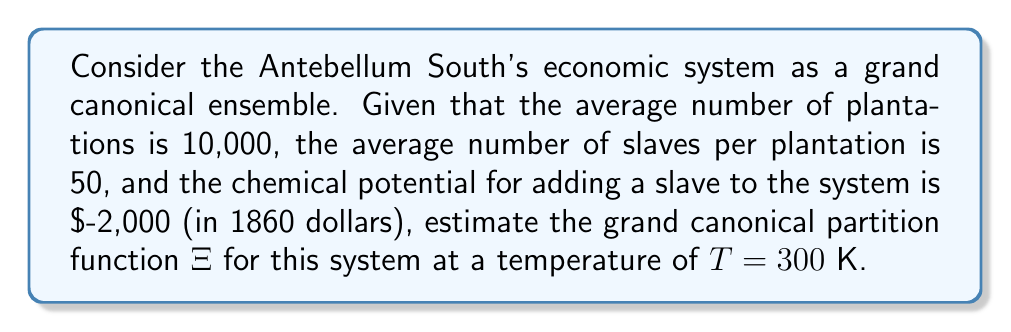What is the answer to this math problem? To estimate the grand canonical partition function for the Antebellum South's economic system, we'll follow these steps:

1) The grand canonical partition function is given by:
   $$\Xi = \sum_{N=0}^{\infty} e^{\beta\mu N} Z_N(T,V)$$
   where $\beta = \frac{1}{k_BT}$, $\mu$ is the chemical potential, $N$ is the number of particles (slaves in this case), and $Z_N$ is the canonical partition function.

2) We don't have the exact form of $Z_N$, but we can make an approximation using the given information:
   - Average number of plantations: $M = 10,000$
   - Average number of slaves per plantation: $n = 50$
   - Total average number of slaves: $\langle N \rangle = M \times n = 500,000$

3) In the grand canonical ensemble, the average number of particles is related to the chemical potential by:
   $$\langle N \rangle = -\frac{\partial (\beta \Omega)}{\partial (\beta \mu)}$$
   where $\Omega = -k_BT \ln \Xi$ is the grand potential.

4) For large systems, we can approximate:
   $$\ln \Xi \approx \beta \mu \langle N \rangle$$

5) Substituting the given values:
   $\mu = -2,000$ (in 1860 dollars)
   $T = 300$ K
   $k_B \approx 1.38 \times 10^{-23}$ J/K

6) Calculate $\beta$:
   $$\beta = \frac{1}{k_BT} = \frac{1}{(1.38 \times 10^{-23})(300)} \approx 2.42 \times 10^{20}$$

7) Now we can estimate $\ln \Xi$:
   $$\ln \Xi \approx (2.42 \times 10^{20})(-2,000)(500,000) = -2.42 \times 10^{26}$$

8) Therefore, the grand canonical partition function $\Xi$ is approximately:
   $$\Xi \approx e^{-2.42 \times 10^{26}}$$

This is an extremely small number, reflecting the highly unfavorable energetics of the slave-based economic system.
Answer: $\Xi \approx e^{-2.42 \times 10^{26}}$ 